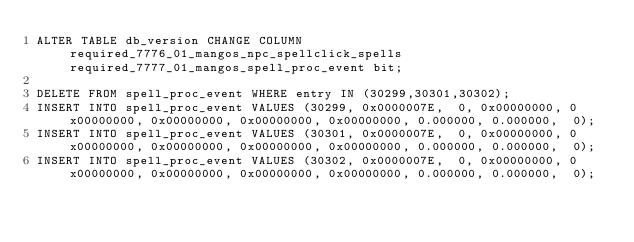Convert code to text. <code><loc_0><loc_0><loc_500><loc_500><_SQL_>ALTER TABLE db_version CHANGE COLUMN required_7776_01_mangos_npc_spellclick_spells required_7777_01_mangos_spell_proc_event bit;

DELETE FROM spell_proc_event WHERE entry IN (30299,30301,30302);
INSERT INTO spell_proc_event VALUES (30299, 0x0000007E,  0, 0x00000000, 0x00000000, 0x00000000, 0x00000000, 0x00000000, 0.000000, 0.000000,  0);
INSERT INTO spell_proc_event VALUES (30301, 0x0000007E,  0, 0x00000000, 0x00000000, 0x00000000, 0x00000000, 0x00000000, 0.000000, 0.000000,  0);
INSERT INTO spell_proc_event VALUES (30302, 0x0000007E,  0, 0x00000000, 0x00000000, 0x00000000, 0x00000000, 0x00000000, 0.000000, 0.000000,  0);
</code> 